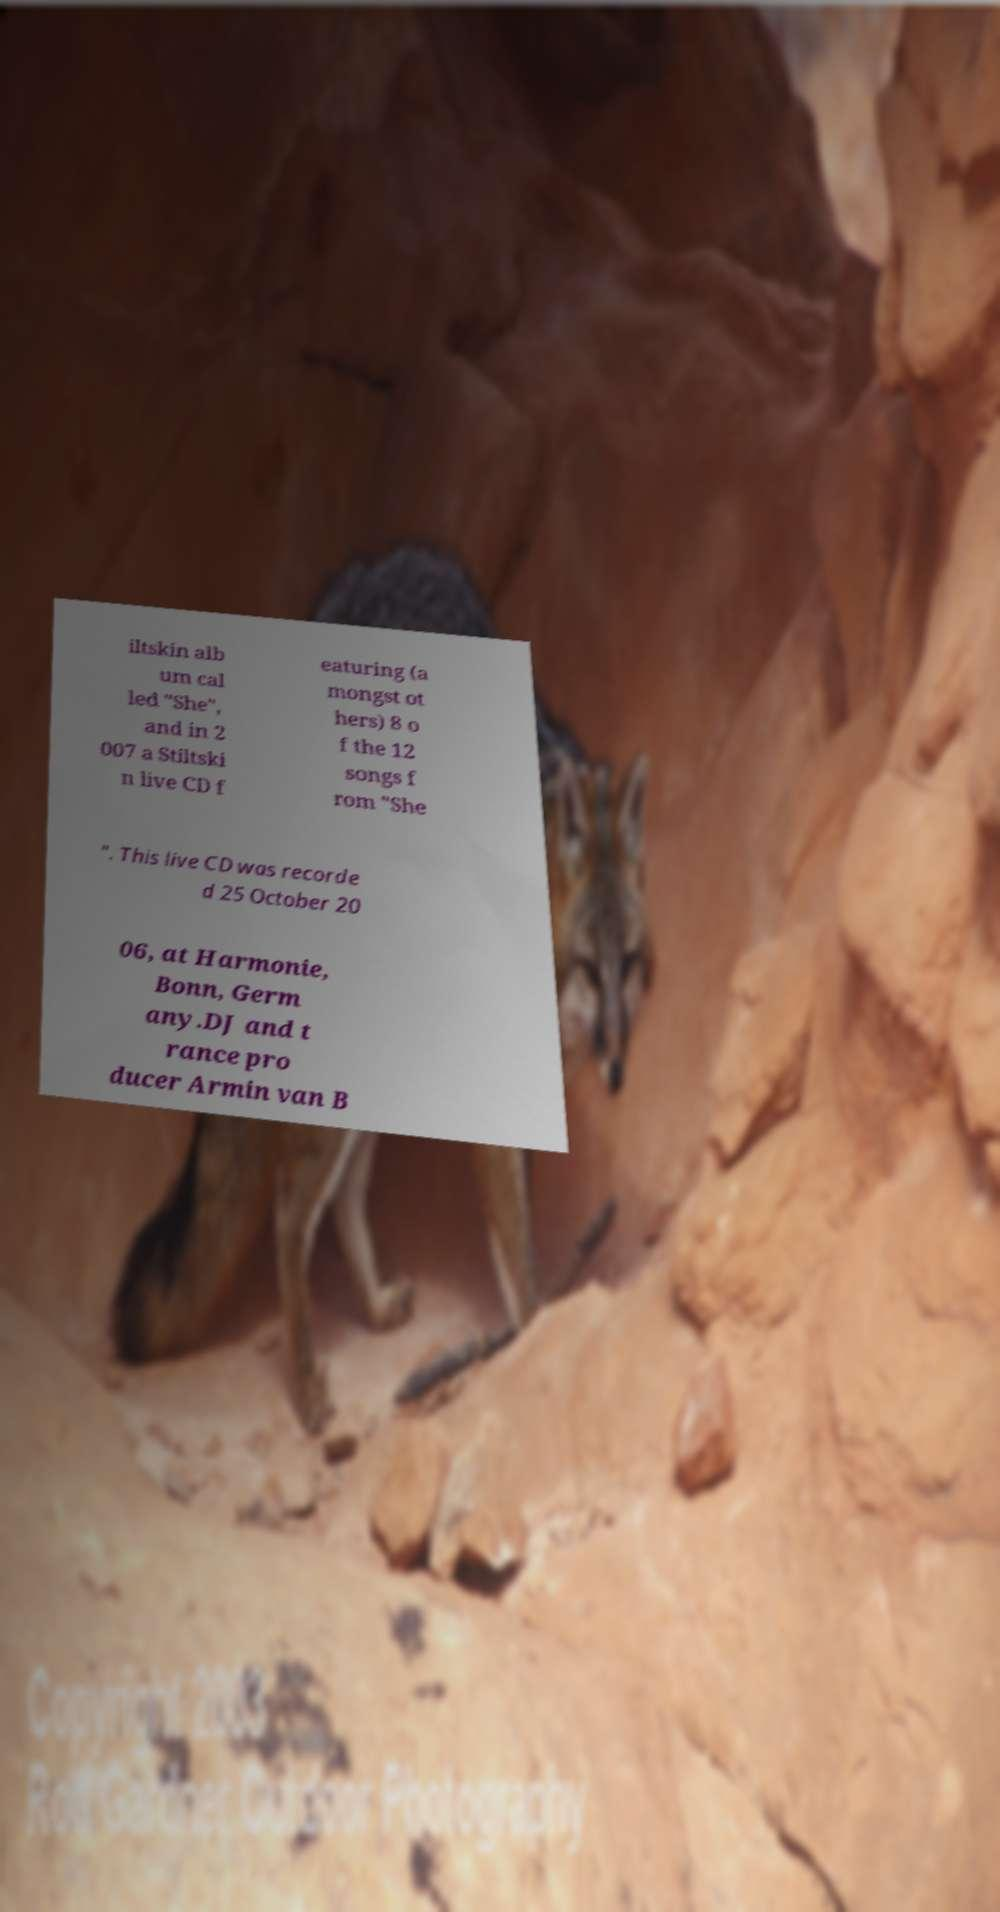Could you extract and type out the text from this image? iltskin alb um cal led "She", and in 2 007 a Stiltski n live CD f eaturing (a mongst ot hers) 8 o f the 12 songs f rom "She ". This live CD was recorde d 25 October 20 06, at Harmonie, Bonn, Germ any.DJ and t rance pro ducer Armin van B 